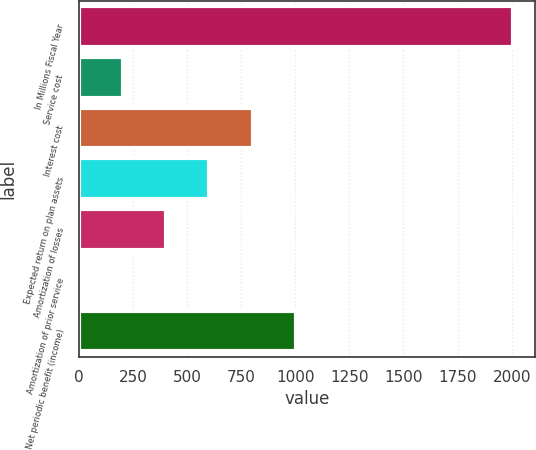Convert chart to OTSL. <chart><loc_0><loc_0><loc_500><loc_500><bar_chart><fcel>In Millions Fiscal Year<fcel>Service cost<fcel>Interest cost<fcel>Expected return on plan assets<fcel>Amortization of losses<fcel>Amortization of prior service<fcel>Net periodic benefit (income)<nl><fcel>2006<fcel>202.4<fcel>803.6<fcel>603.2<fcel>402.8<fcel>2<fcel>1004<nl></chart> 